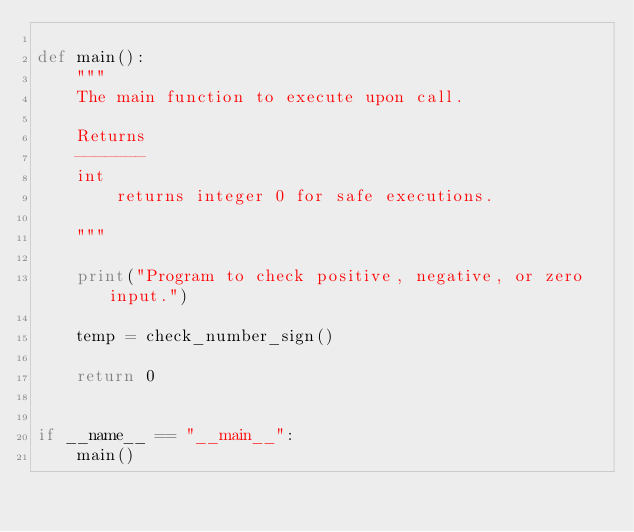Convert code to text. <code><loc_0><loc_0><loc_500><loc_500><_Python_>
def main():
    """
    The main function to execute upon call.

    Returns
    -------
    int
        returns integer 0 for safe executions.

    """

    print("Program to check positive, negative, or zero input.")

    temp = check_number_sign()

    return 0


if __name__ == "__main__":
    main()
</code> 